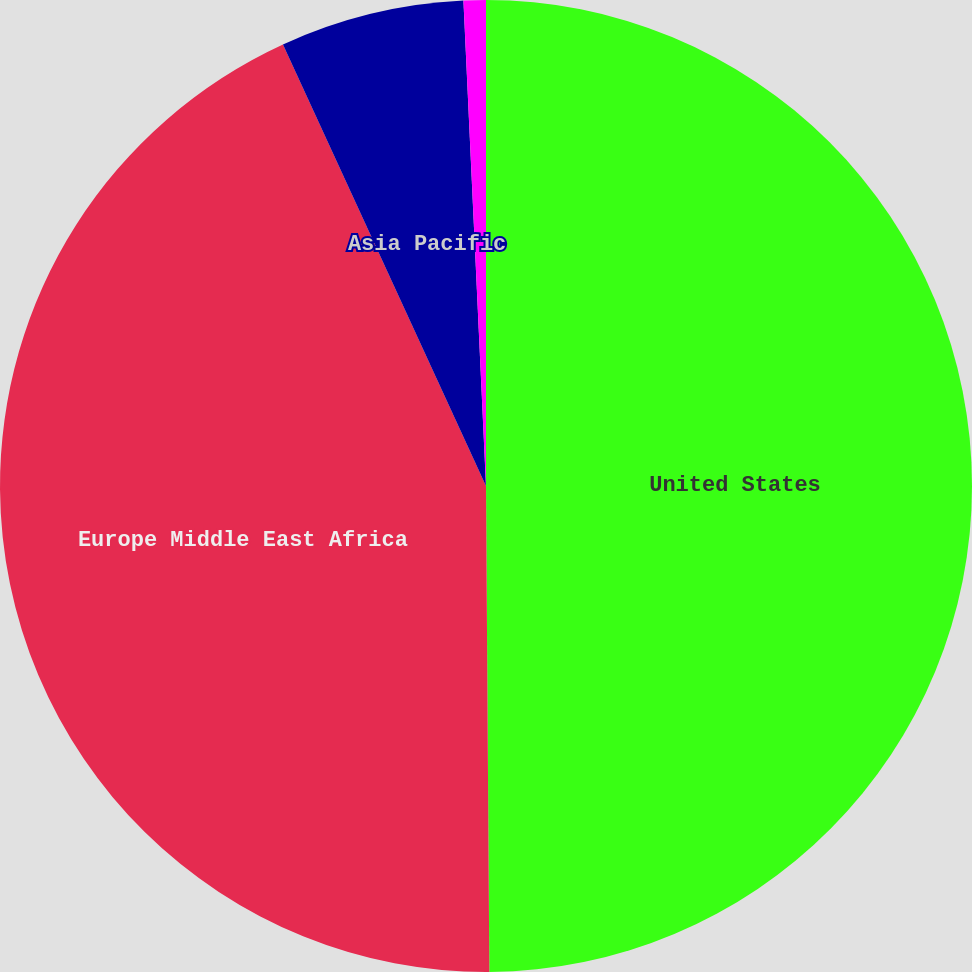<chart> <loc_0><loc_0><loc_500><loc_500><pie_chart><fcel>United States<fcel>Europe Middle East Africa<fcel>Asia Pacific<fcel>Other foreign countries<nl><fcel>49.89%<fcel>43.25%<fcel>6.12%<fcel>0.74%<nl></chart> 